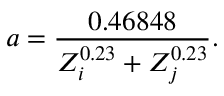Convert formula to latex. <formula><loc_0><loc_0><loc_500><loc_500>a = \frac { 0 . 4 6 8 4 8 } { Z _ { i } ^ { 0 . 2 3 } + Z _ { j } ^ { 0 . 2 3 } } .</formula> 